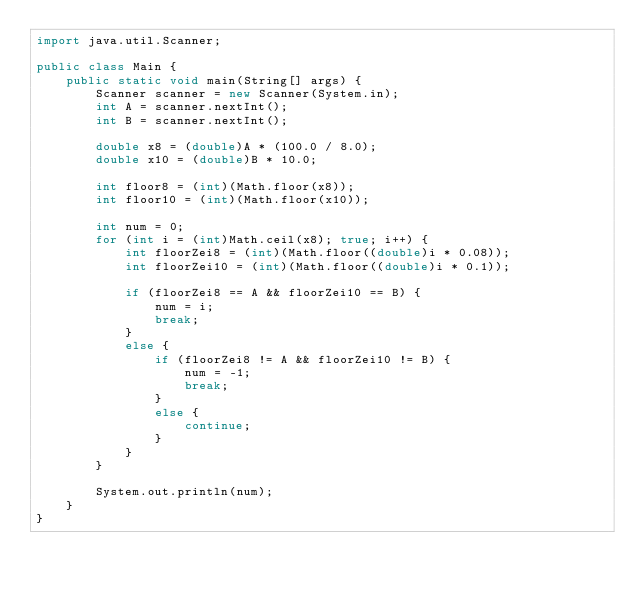Convert code to text. <code><loc_0><loc_0><loc_500><loc_500><_Java_>import java.util.Scanner;

public class Main {
	public static void main(String[] args) {
		Scanner scanner = new Scanner(System.in);
		int A = scanner.nextInt();
		int B = scanner.nextInt();

		double x8 = (double)A * (100.0 / 8.0);
		double x10 = (double)B * 10.0;

		int floor8 = (int)(Math.floor(x8));
		int floor10 = (int)(Math.floor(x10));

		int num = 0;
		for (int i = (int)Math.ceil(x8); true; i++) {
			int floorZei8 = (int)(Math.floor((double)i * 0.08));
			int floorZei10 = (int)(Math.floor((double)i * 0.1));

			if (floorZei8 == A && floorZei10 == B) {
				num = i;
				break;
			}
			else {
				if (floorZei8 != A && floorZei10 != B) {
					num = -1;
					break;
				}
				else {
					continue;
				}
			}
		}

		System.out.println(num);
	}
}</code> 